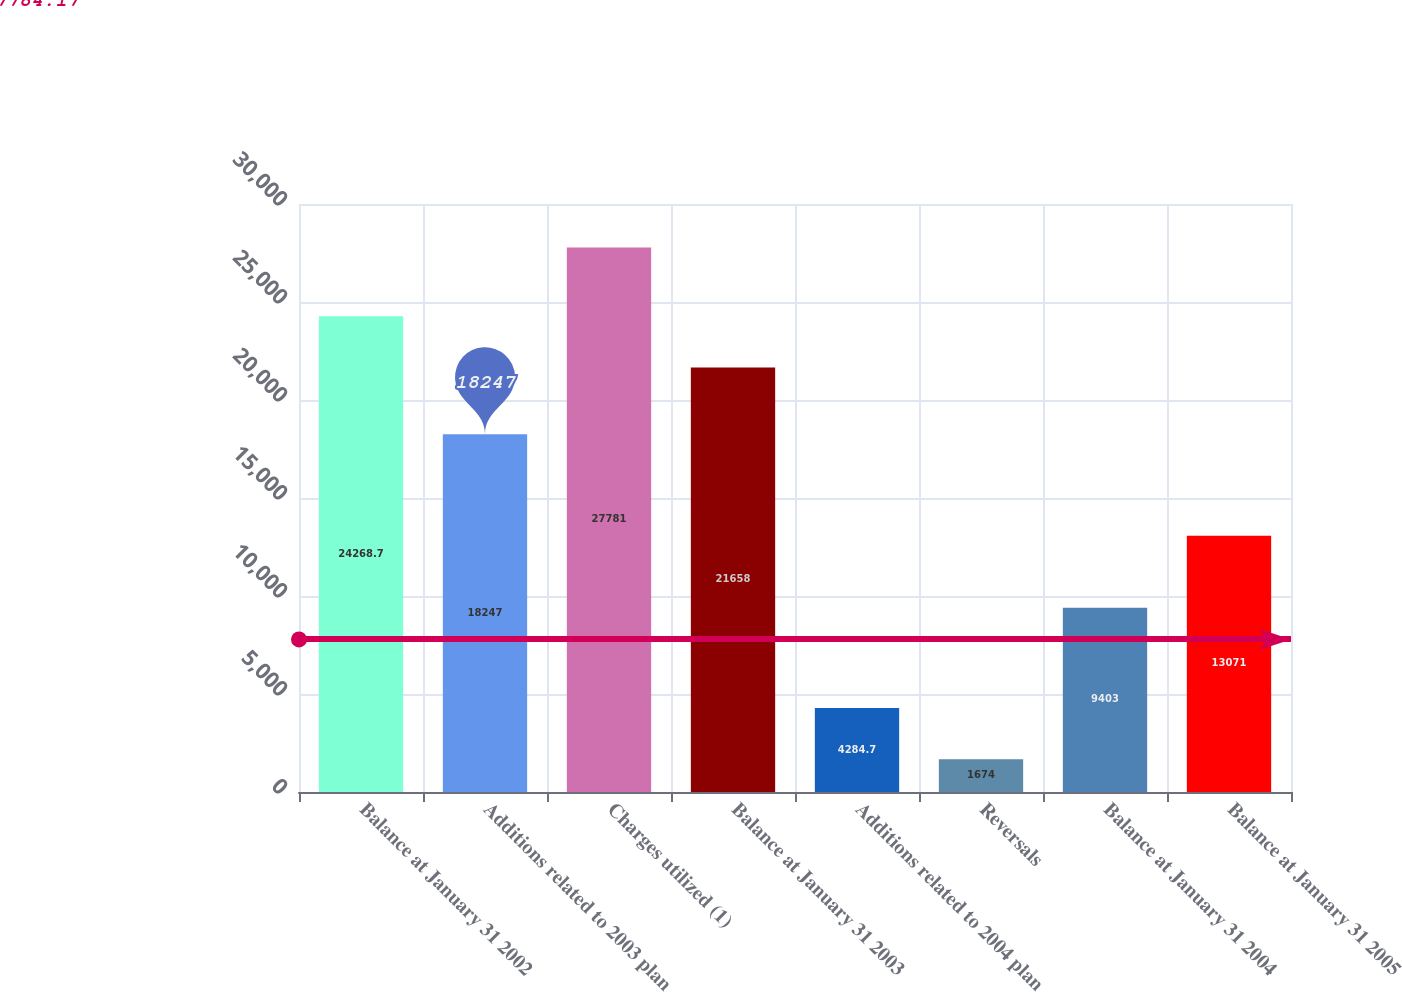<chart> <loc_0><loc_0><loc_500><loc_500><bar_chart><fcel>Balance at January 31 2002<fcel>Additions related to 2003 plan<fcel>Charges utilized (1)<fcel>Balance at January 31 2003<fcel>Additions related to 2004 plan<fcel>Reversals<fcel>Balance at January 31 2004<fcel>Balance at January 31 2005<nl><fcel>24268.7<fcel>18247<fcel>27781<fcel>21658<fcel>4284.7<fcel>1674<fcel>9403<fcel>13071<nl></chart> 